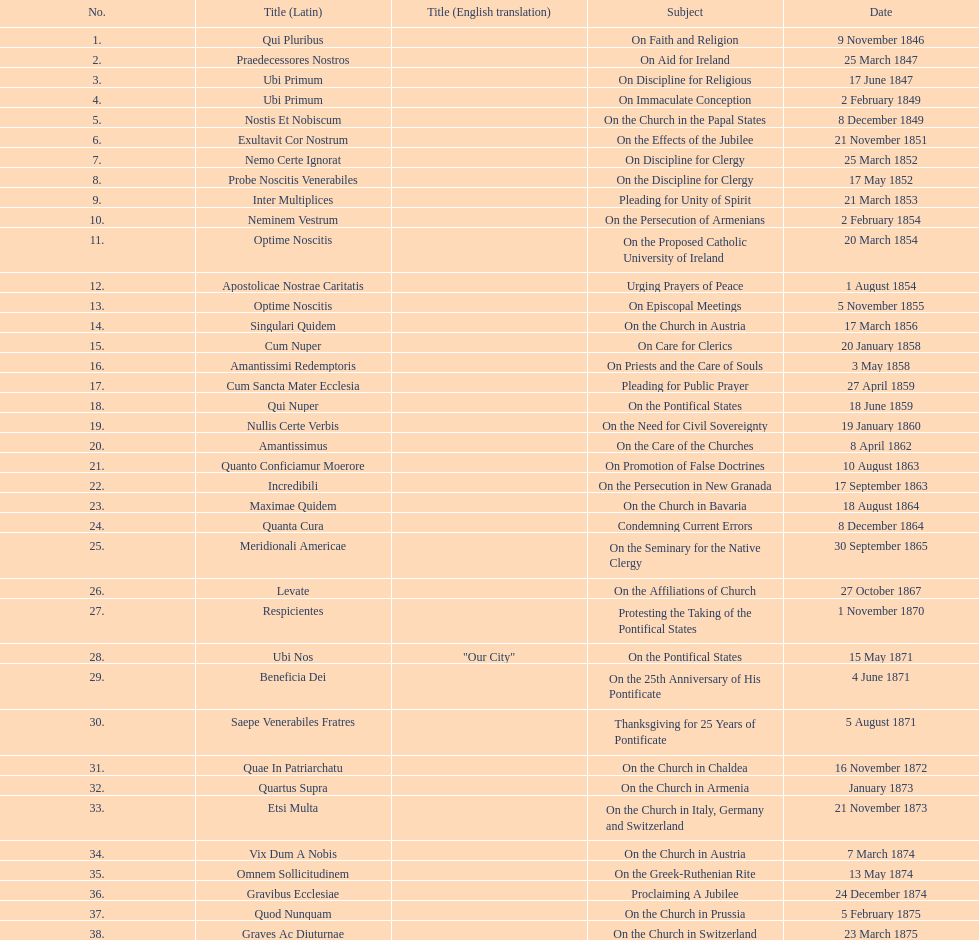Can you provide the latin name for the encyclical that came before the one addressing "on the church in bavaria"? Incredibili. 